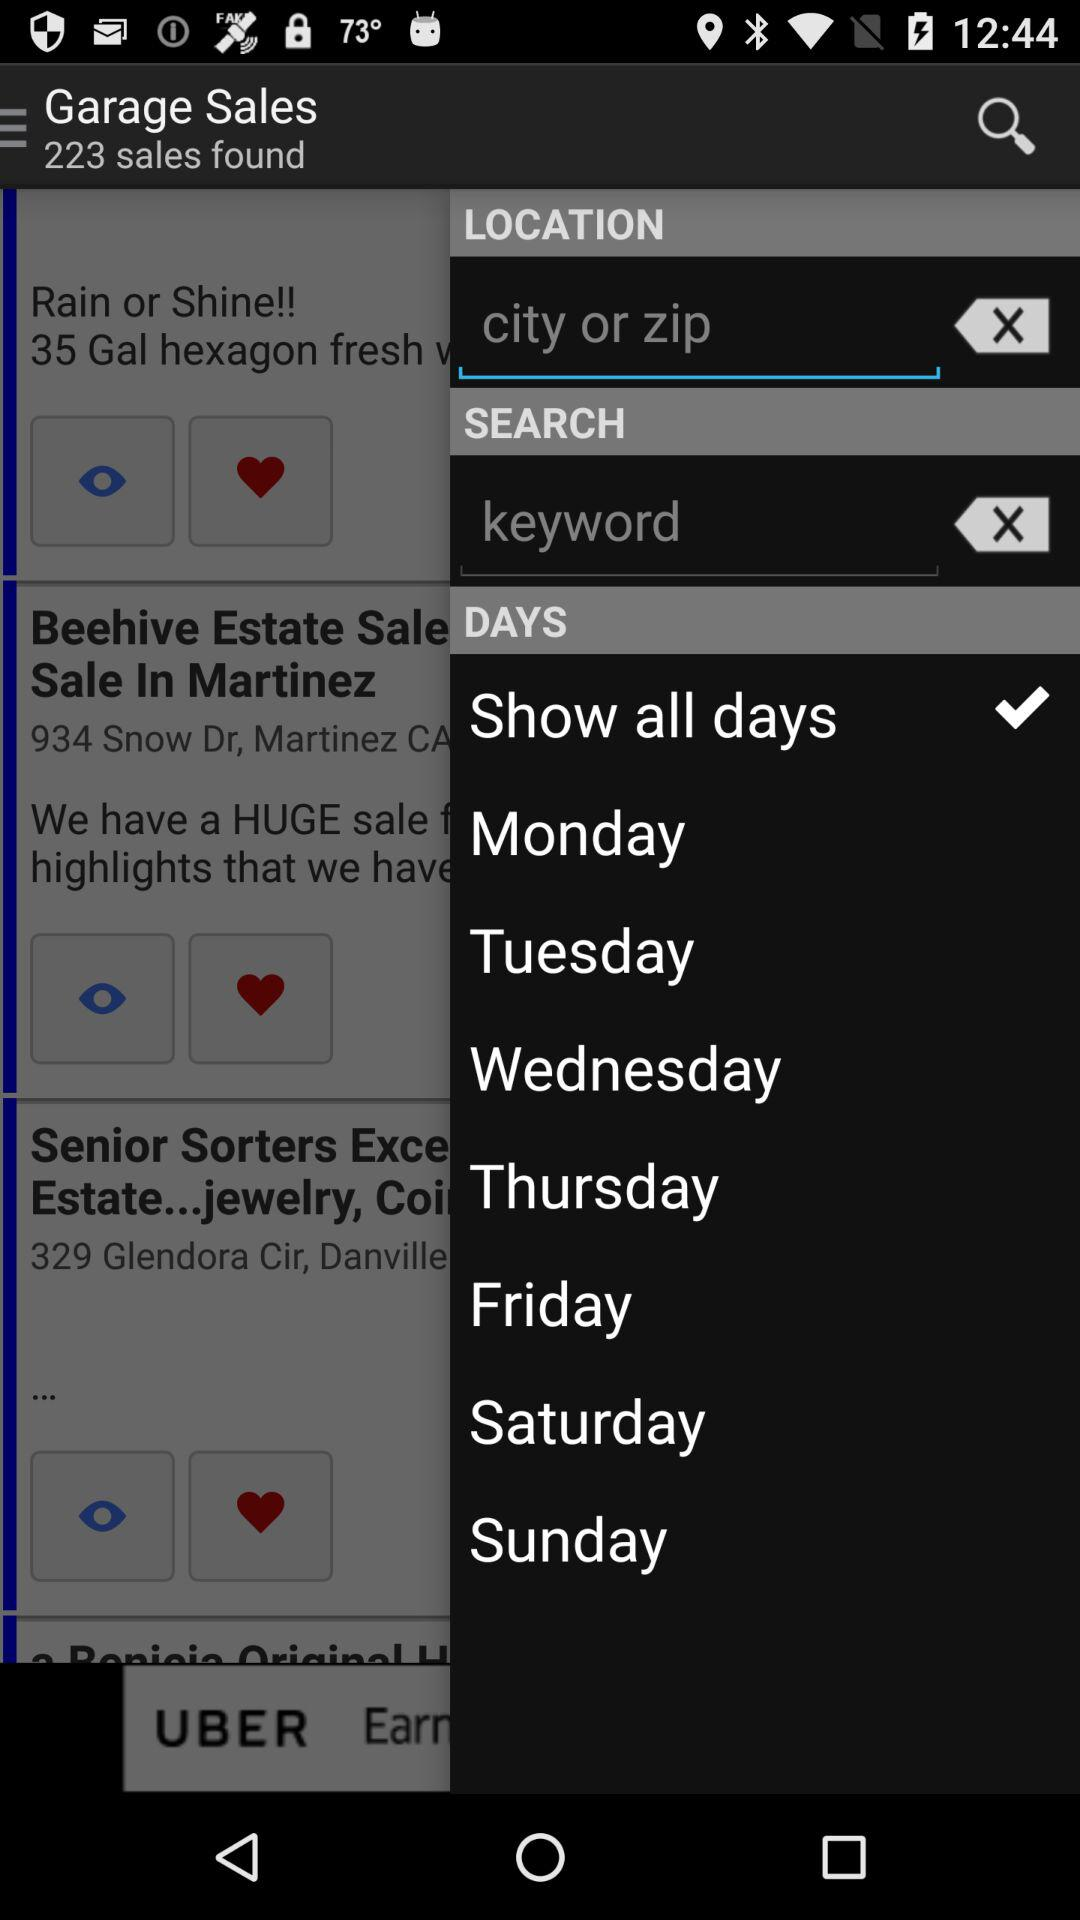Which option is selected in "DAYS"? The selected option is " Show all days". 